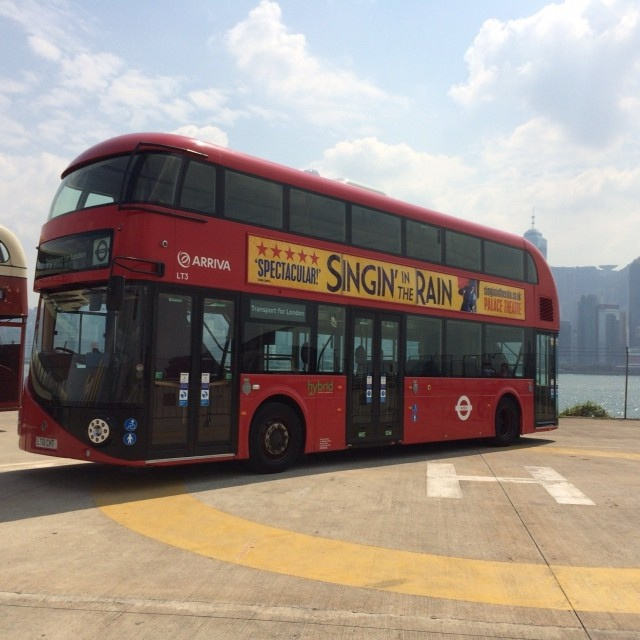Describe the objects in this image and their specific colors. I can see bus in lightgray, black, maroon, gray, and purple tones in this image. 